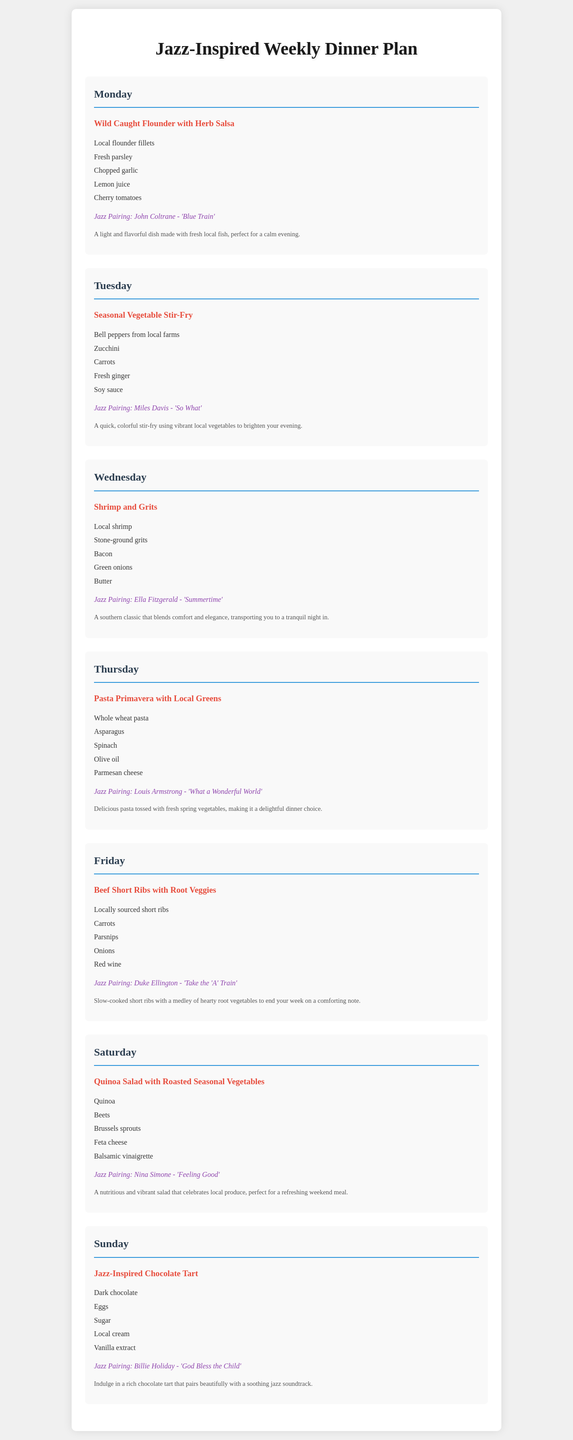What is featured on Monday's dinner plan? The document features "Wild Caught Flounder with Herb Salsa" for Monday's dinner.
Answer: Wild Caught Flounder with Herb Salsa What jazz pairing is suggested for Tuesday's meal? The jazz pairing for Tuesday's meal is associated with the dish on that day, which is "Seasonal Vegetable Stir-Fry".
Answer: Miles Davis - 'So What' How many ingredients are listed for the Shrimp and Grits? The ingredients for Shrimp and Grits are listed, and there are five items in total.
Answer: 5 What type of pasta is used in Thursday's dinner? Thursday’s dinner plan specifies the type of pasta used as "whole wheat".
Answer: Whole wheat pasta Which meal includes dark chocolate as an ingredient? The dessert on Sunday features dark chocolate as one of its key ingredients.
Answer: Jazz-Inspired Chocolate Tart Which day features locally sourced short ribs? The meal scheduled for Friday features locally sourced short ribs.
Answer: Friday What meal is highlighted for a nutritious weekend option? Saturday's dinner is noted for a nutritious meal option with a focus on local produce.
Answer: Quinoa Salad with Roasted Seasonal Vegetables Which meal pairs with Billie Holiday's music? Sunday’s dessert is paired with Billie Holiday’s music, complementing the dish.
Answer: Jazz-Inspired Chocolate Tart What is the main protein in Wednesday's dinner recipe? The main protein in Wednesday's dinner recipe is shrimp.
Answer: Shrimp 